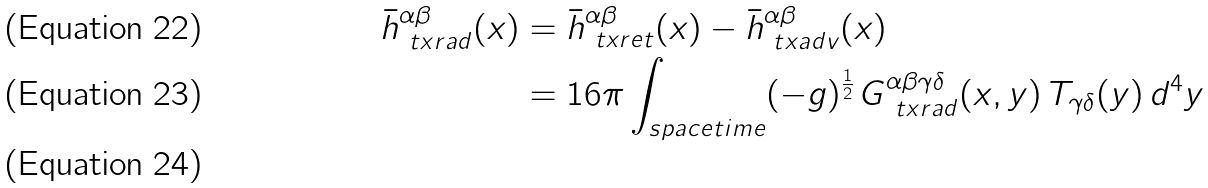<formula> <loc_0><loc_0><loc_500><loc_500>\bar { h } _ { \ t x { r a d } } ^ { \alpha \beta } ( x ) & = \bar { h } ^ { \alpha \beta } _ { \ t x { r e t } } ( x ) - \bar { h } ^ { \alpha \beta } _ { \ t x { a d v } } ( x ) \\ & = 1 6 \pi \int _ { s p a c e t i m e } ( - g ) ^ { \frac { 1 } { 2 } } \, G _ { \ t x { r a d } } ^ { \alpha \beta \gamma \delta } ( x , y ) \, T _ { \gamma \delta } ( y ) \, d ^ { 4 } y \\</formula> 